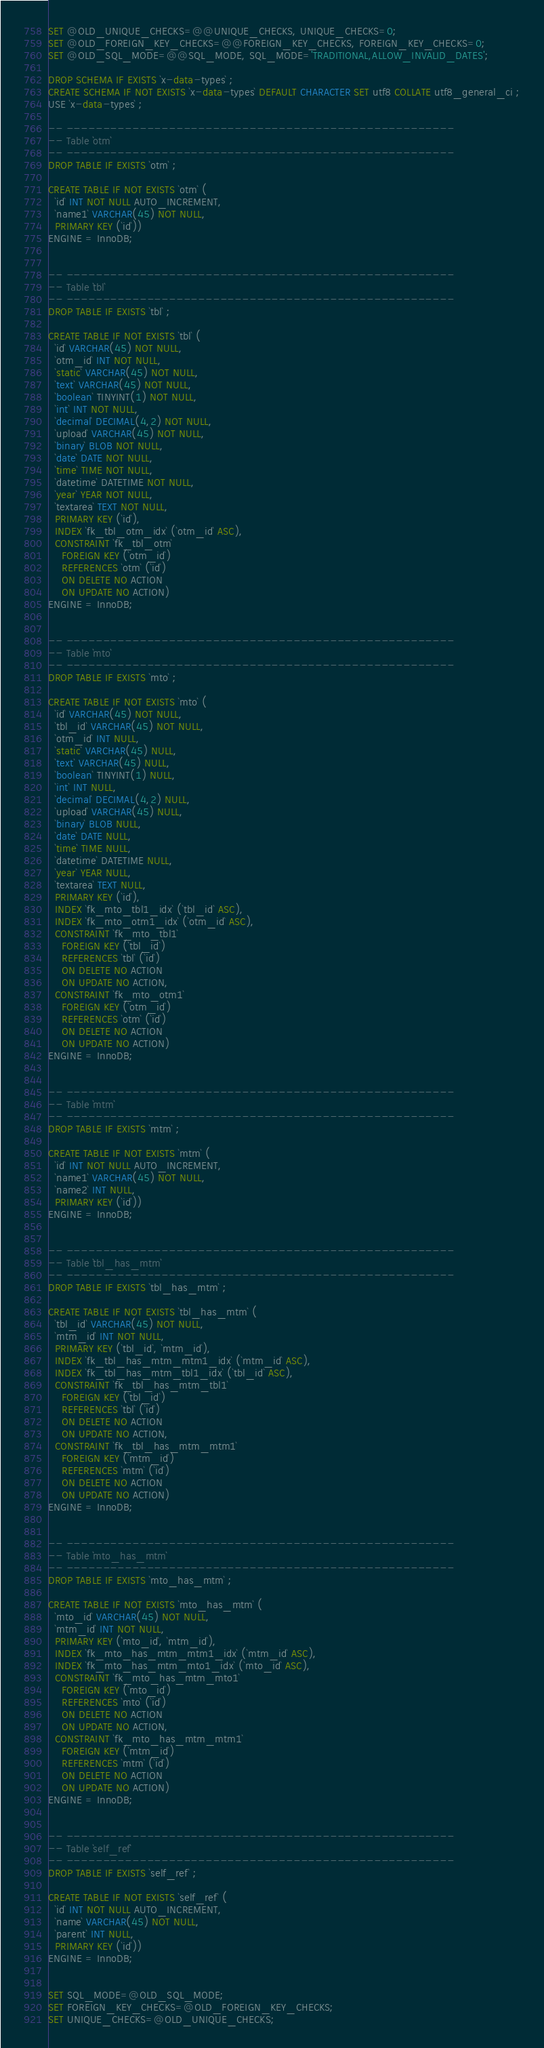Convert code to text. <code><loc_0><loc_0><loc_500><loc_500><_SQL_>SET @OLD_UNIQUE_CHECKS=@@UNIQUE_CHECKS, UNIQUE_CHECKS=0;
SET @OLD_FOREIGN_KEY_CHECKS=@@FOREIGN_KEY_CHECKS, FOREIGN_KEY_CHECKS=0;
SET @OLD_SQL_MODE=@@SQL_MODE, SQL_MODE='TRADITIONAL,ALLOW_INVALID_DATES';

DROP SCHEMA IF EXISTS `x-data-types` ;
CREATE SCHEMA IF NOT EXISTS `x-data-types` DEFAULT CHARACTER SET utf8 COLLATE utf8_general_ci ;
USE `x-data-types` ;

-- -----------------------------------------------------
-- Table `otm`
-- -----------------------------------------------------
DROP TABLE IF EXISTS `otm` ;

CREATE TABLE IF NOT EXISTS `otm` (
  `id` INT NOT NULL AUTO_INCREMENT,
  `name1` VARCHAR(45) NOT NULL,
  PRIMARY KEY (`id`))
ENGINE = InnoDB;


-- -----------------------------------------------------
-- Table `tbl`
-- -----------------------------------------------------
DROP TABLE IF EXISTS `tbl` ;

CREATE TABLE IF NOT EXISTS `tbl` (
  `id` VARCHAR(45) NOT NULL,
  `otm_id` INT NOT NULL,
  `static` VARCHAR(45) NOT NULL,
  `text` VARCHAR(45) NOT NULL,
  `boolean` TINYINT(1) NOT NULL,
  `int` INT NOT NULL,
  `decimal` DECIMAL(4,2) NOT NULL,
  `upload` VARCHAR(45) NOT NULL,
  `binary` BLOB NOT NULL,
  `date` DATE NOT NULL,
  `time` TIME NOT NULL,
  `datetime` DATETIME NOT NULL,
  `year` YEAR NOT NULL,
  `textarea` TEXT NOT NULL,
  PRIMARY KEY (`id`),
  INDEX `fk_tbl_otm_idx` (`otm_id` ASC),
  CONSTRAINT `fk_tbl_otm`
    FOREIGN KEY (`otm_id`)
    REFERENCES `otm` (`id`)
    ON DELETE NO ACTION
    ON UPDATE NO ACTION)
ENGINE = InnoDB;


-- -----------------------------------------------------
-- Table `mto`
-- -----------------------------------------------------
DROP TABLE IF EXISTS `mto` ;

CREATE TABLE IF NOT EXISTS `mto` (
  `id` VARCHAR(45) NOT NULL,
  `tbl_id` VARCHAR(45) NOT NULL,
  `otm_id` INT NULL,
  `static` VARCHAR(45) NULL,
  `text` VARCHAR(45) NULL,
  `boolean` TINYINT(1) NULL,
  `int` INT NULL,
  `decimal` DECIMAL(4,2) NULL,
  `upload` VARCHAR(45) NULL,
  `binary` BLOB NULL,
  `date` DATE NULL,
  `time` TIME NULL,
  `datetime` DATETIME NULL,
  `year` YEAR NULL,
  `textarea` TEXT NULL,
  PRIMARY KEY (`id`),
  INDEX `fk_mto_tbl1_idx` (`tbl_id` ASC),
  INDEX `fk_mto_otm1_idx` (`otm_id` ASC),
  CONSTRAINT `fk_mto_tbl1`
    FOREIGN KEY (`tbl_id`)
    REFERENCES `tbl` (`id`)
    ON DELETE NO ACTION
    ON UPDATE NO ACTION,
  CONSTRAINT `fk_mto_otm1`
    FOREIGN KEY (`otm_id`)
    REFERENCES `otm` (`id`)
    ON DELETE NO ACTION
    ON UPDATE NO ACTION)
ENGINE = InnoDB;


-- -----------------------------------------------------
-- Table `mtm`
-- -----------------------------------------------------
DROP TABLE IF EXISTS `mtm` ;

CREATE TABLE IF NOT EXISTS `mtm` (
  `id` INT NOT NULL AUTO_INCREMENT,
  `name1` VARCHAR(45) NOT NULL,
  `name2` INT NULL,
  PRIMARY KEY (`id`))
ENGINE = InnoDB;


-- -----------------------------------------------------
-- Table `tbl_has_mtm`
-- -----------------------------------------------------
DROP TABLE IF EXISTS `tbl_has_mtm` ;

CREATE TABLE IF NOT EXISTS `tbl_has_mtm` (
  `tbl_id` VARCHAR(45) NOT NULL,
  `mtm_id` INT NOT NULL,
  PRIMARY KEY (`tbl_id`, `mtm_id`),
  INDEX `fk_tbl_has_mtm_mtm1_idx` (`mtm_id` ASC),
  INDEX `fk_tbl_has_mtm_tbl1_idx` (`tbl_id` ASC),
  CONSTRAINT `fk_tbl_has_mtm_tbl1`
    FOREIGN KEY (`tbl_id`)
    REFERENCES `tbl` (`id`)
    ON DELETE NO ACTION
    ON UPDATE NO ACTION,
  CONSTRAINT `fk_tbl_has_mtm_mtm1`
    FOREIGN KEY (`mtm_id`)
    REFERENCES `mtm` (`id`)
    ON DELETE NO ACTION
    ON UPDATE NO ACTION)
ENGINE = InnoDB;


-- -----------------------------------------------------
-- Table `mto_has_mtm`
-- -----------------------------------------------------
DROP TABLE IF EXISTS `mto_has_mtm` ;

CREATE TABLE IF NOT EXISTS `mto_has_mtm` (
  `mto_id` VARCHAR(45) NOT NULL,
  `mtm_id` INT NOT NULL,
  PRIMARY KEY (`mto_id`, `mtm_id`),
  INDEX `fk_mto_has_mtm_mtm1_idx` (`mtm_id` ASC),
  INDEX `fk_mto_has_mtm_mto1_idx` (`mto_id` ASC),
  CONSTRAINT `fk_mto_has_mtm_mto1`
    FOREIGN KEY (`mto_id`)
    REFERENCES `mto` (`id`)
    ON DELETE NO ACTION
    ON UPDATE NO ACTION,
  CONSTRAINT `fk_mto_has_mtm_mtm1`
    FOREIGN KEY (`mtm_id`)
    REFERENCES `mtm` (`id`)
    ON DELETE NO ACTION
    ON UPDATE NO ACTION)
ENGINE = InnoDB;


-- -----------------------------------------------------
-- Table `self_ref`
-- -----------------------------------------------------
DROP TABLE IF EXISTS `self_ref` ;

CREATE TABLE IF NOT EXISTS `self_ref` (
  `id` INT NOT NULL AUTO_INCREMENT,
  `name` VARCHAR(45) NOT NULL,
  `parent` INT NULL,
  PRIMARY KEY (`id`))
ENGINE = InnoDB;


SET SQL_MODE=@OLD_SQL_MODE;
SET FOREIGN_KEY_CHECKS=@OLD_FOREIGN_KEY_CHECKS;
SET UNIQUE_CHECKS=@OLD_UNIQUE_CHECKS;
</code> 